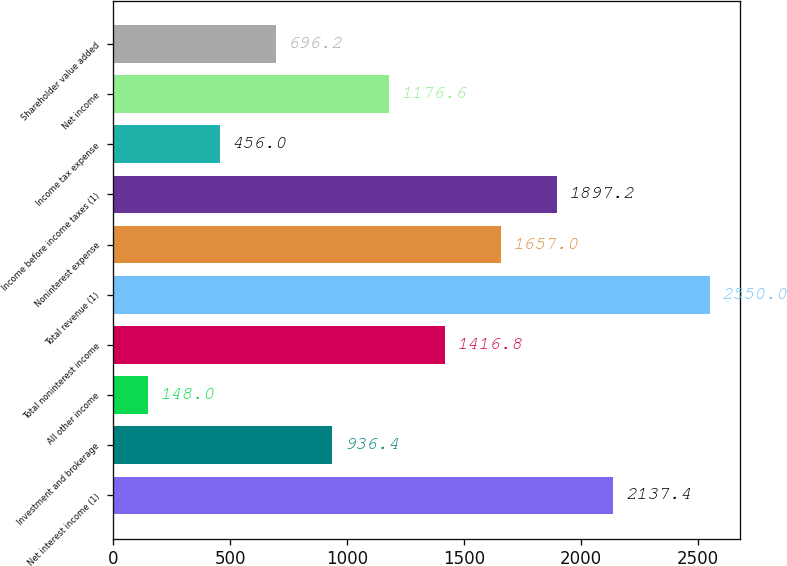Convert chart to OTSL. <chart><loc_0><loc_0><loc_500><loc_500><bar_chart><fcel>Net interest income (1)<fcel>Investment and brokerage<fcel>All other income<fcel>Total noninterest income<fcel>Total revenue (1)<fcel>Noninterest expense<fcel>Income before income taxes (1)<fcel>Income tax expense<fcel>Net income<fcel>Shareholder value added<nl><fcel>2137.4<fcel>936.4<fcel>148<fcel>1416.8<fcel>2550<fcel>1657<fcel>1897.2<fcel>456<fcel>1176.6<fcel>696.2<nl></chart> 